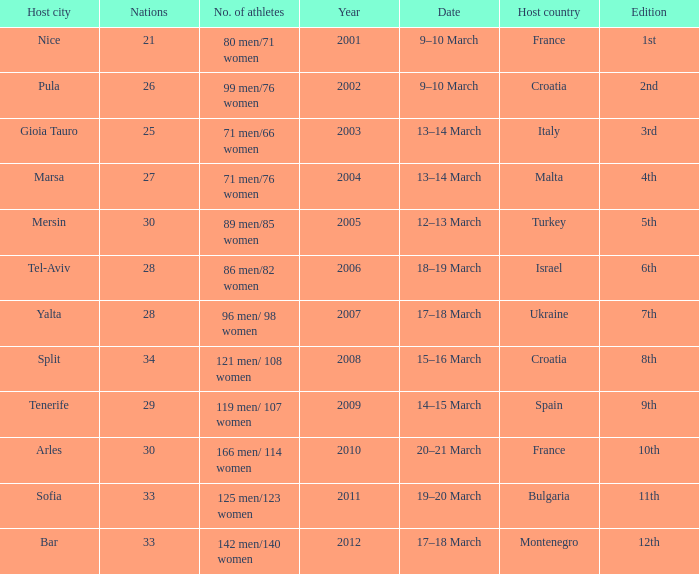What was the number of athletes for the 7th edition? 96 men/ 98 women. 